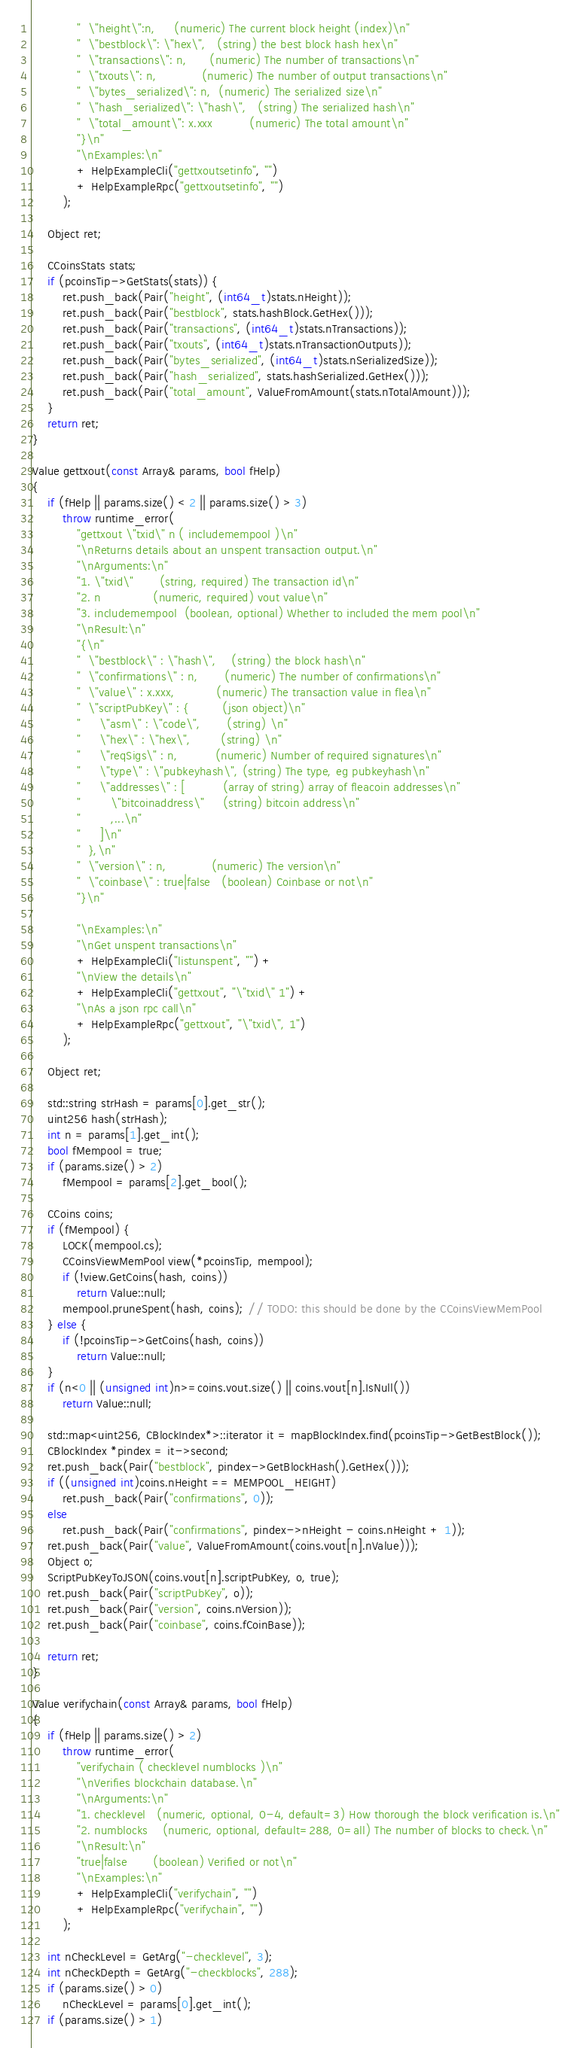<code> <loc_0><loc_0><loc_500><loc_500><_C++_>            "  \"height\":n,     (numeric) The current block height (index)\n"
            "  \"bestblock\": \"hex\",   (string) the best block hash hex\n"
            "  \"transactions\": n,      (numeric) The number of transactions\n"
            "  \"txouts\": n,            (numeric) The number of output transactions\n"
            "  \"bytes_serialized\": n,  (numeric) The serialized size\n"
            "  \"hash_serialized\": \"hash\",   (string) The serialized hash\n"
            "  \"total_amount\": x.xxx          (numeric) The total amount\n"
            "}\n"
            "\nExamples:\n"
            + HelpExampleCli("gettxoutsetinfo", "")
            + HelpExampleRpc("gettxoutsetinfo", "")
        );

    Object ret;

    CCoinsStats stats;
    if (pcoinsTip->GetStats(stats)) {
        ret.push_back(Pair("height", (int64_t)stats.nHeight));
        ret.push_back(Pair("bestblock", stats.hashBlock.GetHex()));
        ret.push_back(Pair("transactions", (int64_t)stats.nTransactions));
        ret.push_back(Pair("txouts", (int64_t)stats.nTransactionOutputs));
        ret.push_back(Pair("bytes_serialized", (int64_t)stats.nSerializedSize));
        ret.push_back(Pair("hash_serialized", stats.hashSerialized.GetHex()));
        ret.push_back(Pair("total_amount", ValueFromAmount(stats.nTotalAmount)));
    }
    return ret;
}

Value gettxout(const Array& params, bool fHelp)
{
    if (fHelp || params.size() < 2 || params.size() > 3)
        throw runtime_error(
            "gettxout \"txid\" n ( includemempool )\n"
            "\nReturns details about an unspent transaction output.\n"
            "\nArguments:\n"
            "1. \"txid\"       (string, required) The transaction id\n"
            "2. n              (numeric, required) vout value\n"
            "3. includemempool  (boolean, optional) Whether to included the mem pool\n"
            "\nResult:\n"
            "{\n"
            "  \"bestblock\" : \"hash\",    (string) the block hash\n"
            "  \"confirmations\" : n,       (numeric) The number of confirmations\n"
            "  \"value\" : x.xxx,           (numeric) The transaction value in flea\n"
            "  \"scriptPubKey\" : {         (json object)\n"
            "     \"asm\" : \"code\",       (string) \n"
            "     \"hex\" : \"hex\",        (string) \n"
            "     \"reqSigs\" : n,          (numeric) Number of required signatures\n"
            "     \"type\" : \"pubkeyhash\", (string) The type, eg pubkeyhash\n"
            "     \"addresses\" : [          (array of string) array of fleacoin addresses\n"
            "        \"bitcoinaddress\"     (string) bitcoin address\n"
            "        ,...\n"
            "     ]\n"
            "  },\n"
            "  \"version\" : n,            (numeric) The version\n"
            "  \"coinbase\" : true|false   (boolean) Coinbase or not\n"
            "}\n"

            "\nExamples:\n"
            "\nGet unspent transactions\n"
            + HelpExampleCli("listunspent", "") +
            "\nView the details\n"
            + HelpExampleCli("gettxout", "\"txid\" 1") +
            "\nAs a json rpc call\n"
            + HelpExampleRpc("gettxout", "\"txid\", 1")
        );

    Object ret;

    std::string strHash = params[0].get_str();
    uint256 hash(strHash);
    int n = params[1].get_int();
    bool fMempool = true;
    if (params.size() > 2)
        fMempool = params[2].get_bool();

    CCoins coins;
    if (fMempool) {
        LOCK(mempool.cs);
        CCoinsViewMemPool view(*pcoinsTip, mempool);
        if (!view.GetCoins(hash, coins))
            return Value::null;
        mempool.pruneSpent(hash, coins); // TODO: this should be done by the CCoinsViewMemPool
    } else {
        if (!pcoinsTip->GetCoins(hash, coins))
            return Value::null;
    }
    if (n<0 || (unsigned int)n>=coins.vout.size() || coins.vout[n].IsNull())
        return Value::null;

    std::map<uint256, CBlockIndex*>::iterator it = mapBlockIndex.find(pcoinsTip->GetBestBlock());
    CBlockIndex *pindex = it->second;
    ret.push_back(Pair("bestblock", pindex->GetBlockHash().GetHex()));
    if ((unsigned int)coins.nHeight == MEMPOOL_HEIGHT)
        ret.push_back(Pair("confirmations", 0));
    else
        ret.push_back(Pair("confirmations", pindex->nHeight - coins.nHeight + 1));
    ret.push_back(Pair("value", ValueFromAmount(coins.vout[n].nValue)));
    Object o;
    ScriptPubKeyToJSON(coins.vout[n].scriptPubKey, o, true);
    ret.push_back(Pair("scriptPubKey", o));
    ret.push_back(Pair("version", coins.nVersion));
    ret.push_back(Pair("coinbase", coins.fCoinBase));

    return ret;
}

Value verifychain(const Array& params, bool fHelp)
{
    if (fHelp || params.size() > 2)
        throw runtime_error(
            "verifychain ( checklevel numblocks )\n"
            "\nVerifies blockchain database.\n"
            "\nArguments:\n"
            "1. checklevel   (numeric, optional, 0-4, default=3) How thorough the block verification is.\n"
            "2. numblocks    (numeric, optional, default=288, 0=all) The number of blocks to check.\n"
            "\nResult:\n"
            "true|false       (boolean) Verified or not\n"
            "\nExamples:\n"
            + HelpExampleCli("verifychain", "")
            + HelpExampleRpc("verifychain", "")
        );

    int nCheckLevel = GetArg("-checklevel", 3);
    int nCheckDepth = GetArg("-checkblocks", 288);
    if (params.size() > 0)
        nCheckLevel = params[0].get_int();
    if (params.size() > 1)</code> 